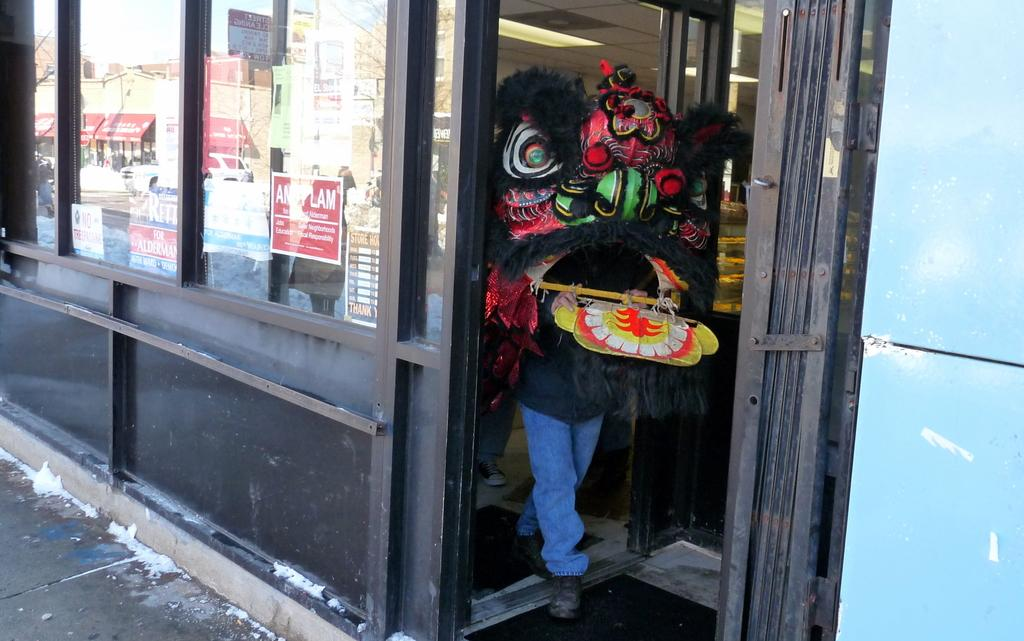What is the person in the image wearing? The person is dressed in a costume in the image. Where is the person standing in the image? The person is standing on the floor in the image. What type of establishments can be seen in the image? There are stores in the image. What objects provide information in the image? Information boards are present in the image. What type of structure is visible in the image? There are walls in the image. What part of the environment is visible beneath the person? The floor is visible in the image. Can you see a kitten wearing a crown in the territory depicted in the image? There is no kitten or crown present in the image, and the concept of territory is not applicable to the given facts. 